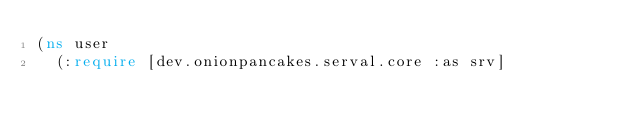<code> <loc_0><loc_0><loc_500><loc_500><_Clojure_>(ns user
  (:require [dev.onionpancakes.serval.core :as srv]</code> 